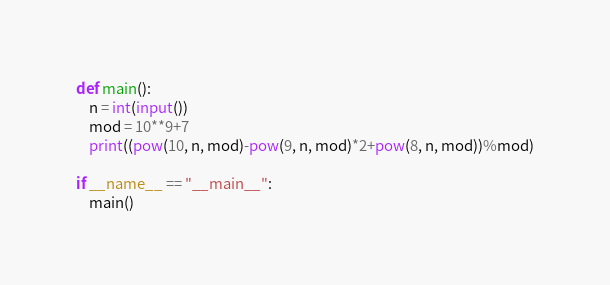<code> <loc_0><loc_0><loc_500><loc_500><_Python_>def main():
    n = int(input())
    mod = 10**9+7
    print((pow(10, n, mod)-pow(9, n, mod)*2+pow(8, n, mod))%mod)

if __name__ == "__main__":
    main()</code> 